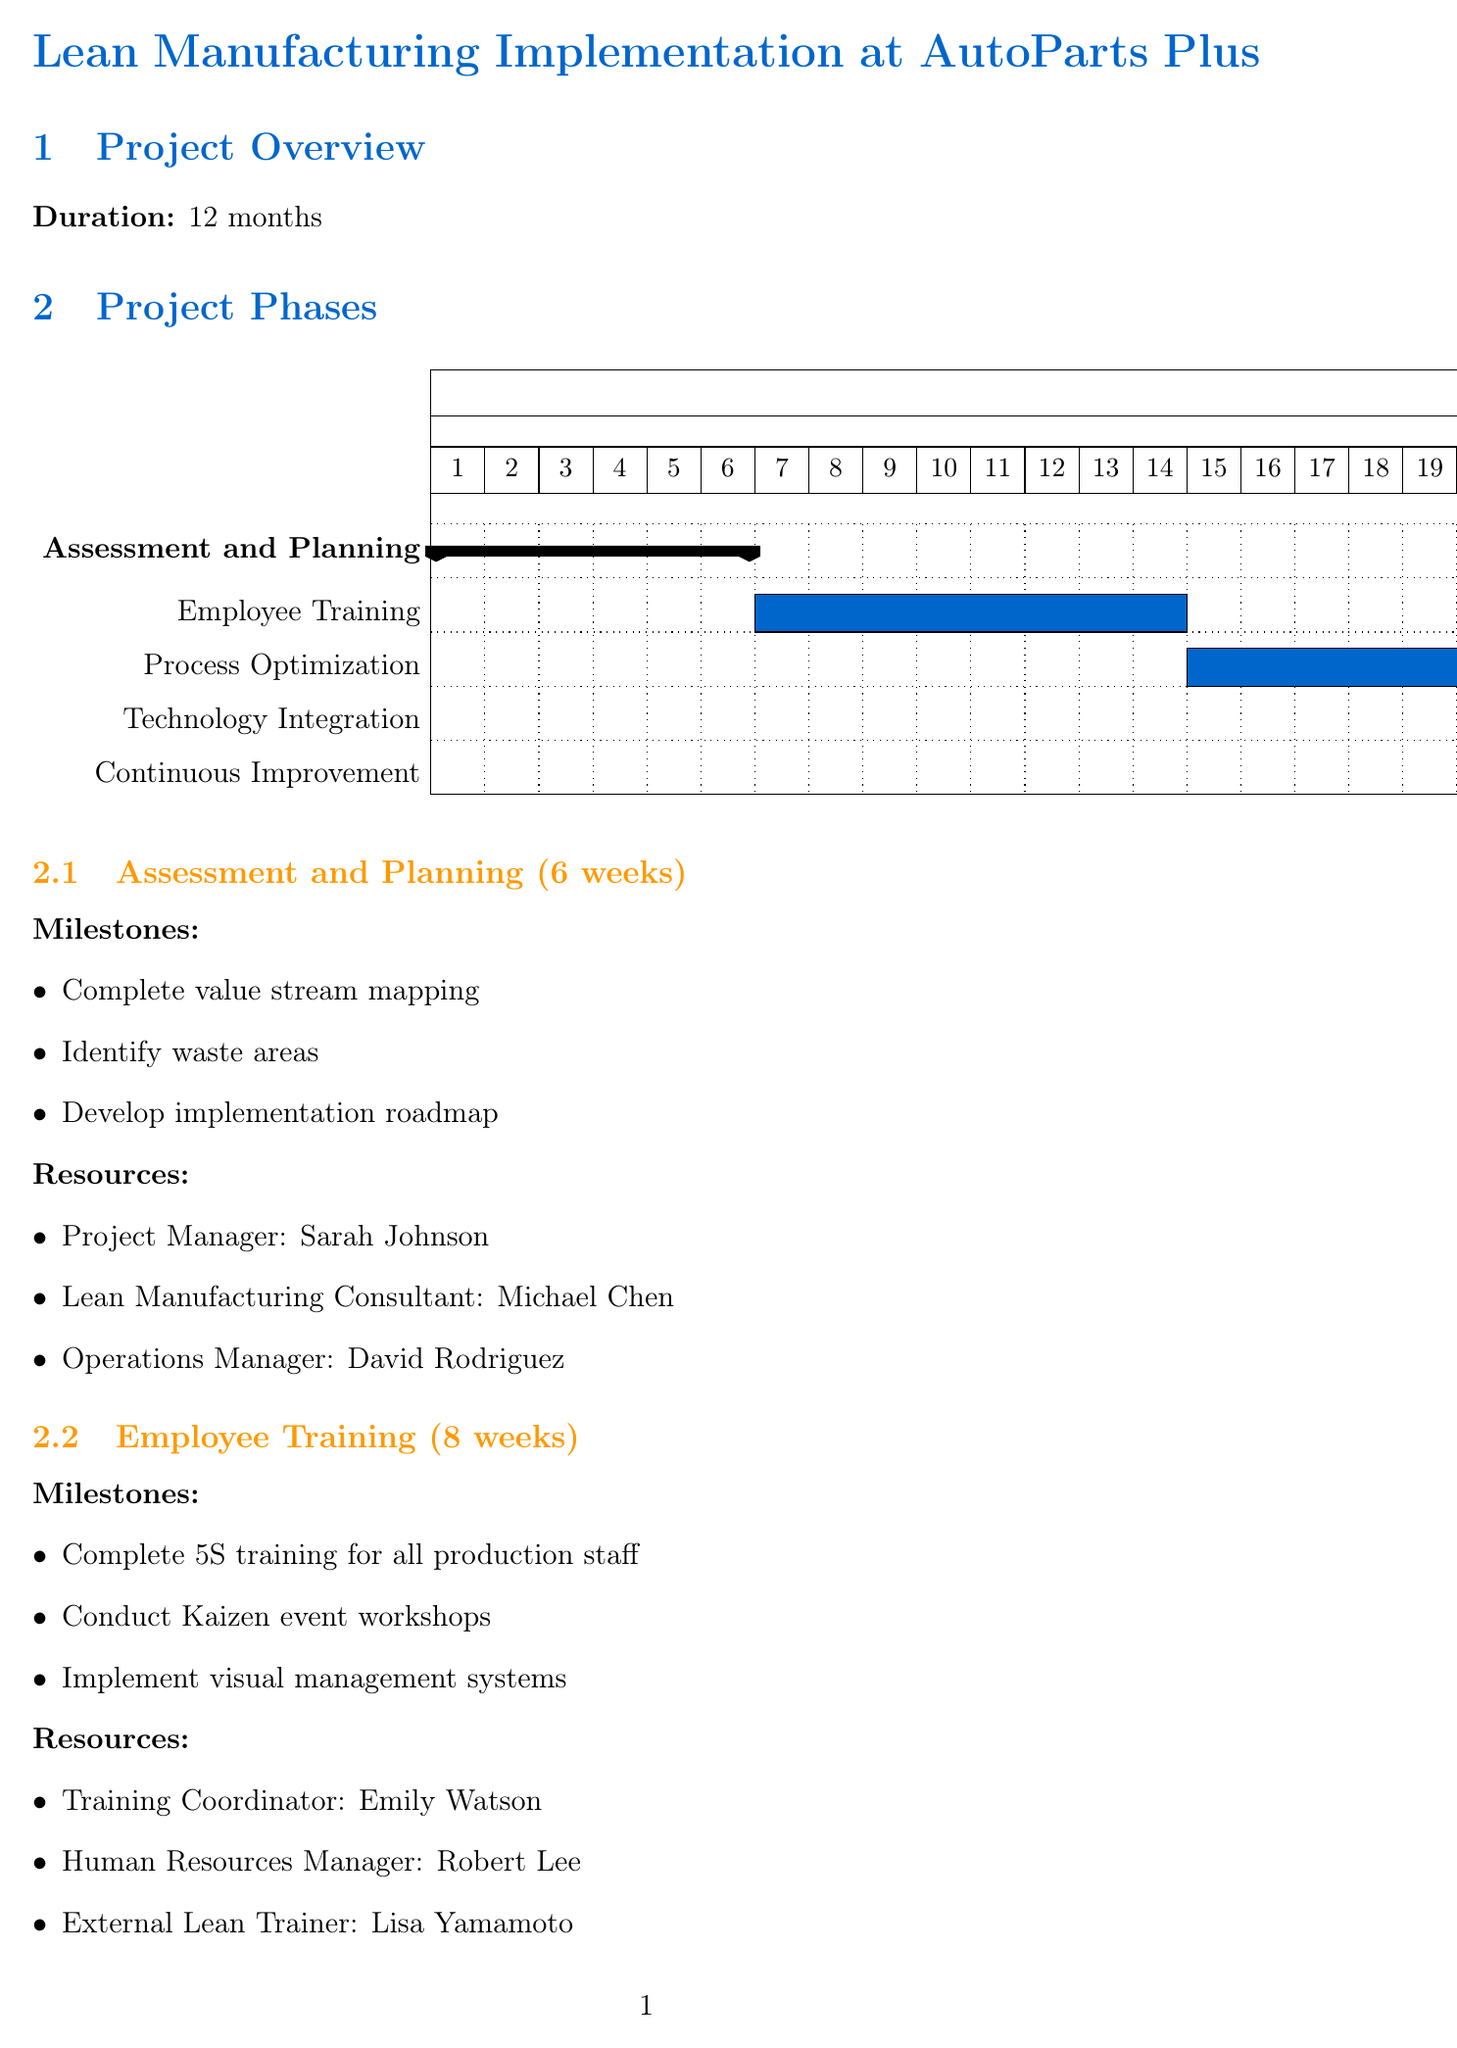what is the total duration of the project? The total duration of the project is specified in the document as 12 months.
Answer: 12 months who is the Quality Manager involved in the project? The document lists the resources for each phase, and the Quality Manager is identified as Carlos Mendoza.
Answer: Carlos Mendoza what is the budget allocation for technology investments? The document outlines the budget allocation, and the amount for technology investments is given as $250,000.
Answer: $250,000 how many weeks does the Process Optimization phase last? The duration of the Process Optimization phase is explicitly stated in the document as 16 weeks.
Answer: 16 weeks which milestone is associated with the Employee Training phase? One of the milestones listed for the Employee Training phase is to conduct Kaizen event workshops, which is specified in the document.
Answer: Conduct Kaizen event workshops which role is responsible for the implementation of the Manufacturing Execution System? The resources in the Technology Integration phase indicate that the IT Project Manager, Jennifer Liu, is responsible for this implementation.
Answer: IT Project Manager: Jennifer Liu what is one expected outcome of the project? The document outlines several expected outcomes, including a 20% reduction in lead time.
Answer: 20% reduction in lead time name one risk factor mentioned in the document. Among the listed risk factors, employee resistance to change is mentioned as a potential challenge in the project.
Answer: Employee resistance to change how many key stakeholders are identified in the project? The document lists three key stakeholders involved in the project.
Answer: 3 